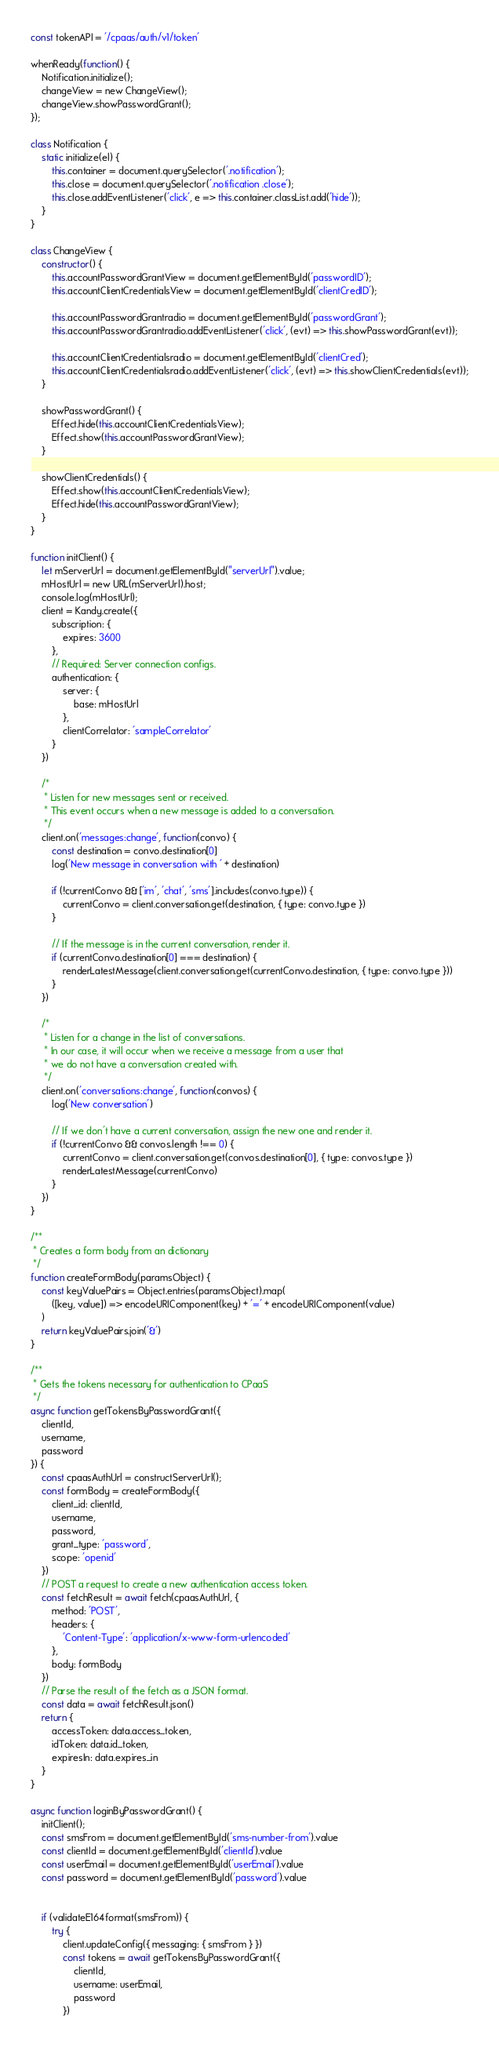Convert code to text. <code><loc_0><loc_0><loc_500><loc_500><_JavaScript_>const tokenAPI = '/cpaas/auth/v1/token'

whenReady(function() {
    Notification.initialize();
    changeView = new ChangeView();
    changeView.showPasswordGrant();
});

class Notification {
    static initialize(el) {
        this.container = document.querySelector('.notification');
        this.close = document.querySelector('.notification .close');
        this.close.addEventListener('click', e => this.container.classList.add('hide'));
    }
}

class ChangeView {
    constructor() {
        this.accountPasswordGrantView = document.getElementById('passwordID');
        this.accountClientCredentialsView = document.getElementById('clientCredID');

        this.accountPasswordGrantradio = document.getElementById('passwordGrant');
        this.accountPasswordGrantradio.addEventListener('click', (evt) => this.showPasswordGrant(evt));

        this.accountClientCredentialsradio = document.getElementById('clientCred');
        this.accountClientCredentialsradio.addEventListener('click', (evt) => this.showClientCredentials(evt));
    }

    showPasswordGrant() {
        Effect.hide(this.accountClientCredentialsView);
        Effect.show(this.accountPasswordGrantView);
    }

    showClientCredentials() {
        Effect.show(this.accountClientCredentialsView);
        Effect.hide(this.accountPasswordGrantView);
    }
}

function initClient() {
    let mServerUrl = document.getElementById("serverUrl").value;
    mHostUrl = new URL(mServerUrl).host;
    console.log(mHostUrl);
    client = Kandy.create({
        subscription: {
            expires: 3600
        },
        // Required: Server connection configs.
        authentication: {
            server: {
                base: mHostUrl
            },
            clientCorrelator: 'sampleCorrelator'
        }
    })

    /*
     * Listen for new messages sent or received.
     * This event occurs when a new message is added to a conversation.
     */
    client.on('messages:change', function(convo) {
        const destination = convo.destination[0]
        log('New message in conversation with ' + destination)

        if (!currentConvo && ['im', 'chat', 'sms'].includes(convo.type)) {
            currentConvo = client.conversation.get(destination, { type: convo.type })
        }

        // If the message is in the current conversation, render it.
        if (currentConvo.destination[0] === destination) {
            renderLatestMessage(client.conversation.get(currentConvo.destination, { type: convo.type }))
        }
    })

    /*
     * Listen for a change in the list of conversations.
     * In our case, it will occur when we receive a message from a user that
     * we do not have a conversation created with.
     */
    client.on('conversations:change', function(convos) {
        log('New conversation')

        // If we don't have a current conversation, assign the new one and render it.
        if (!currentConvo && convos.length !== 0) {
            currentConvo = client.conversation.get(convos.destination[0], { type: convos.type })
            renderLatestMessage(currentConvo)
        }
    })
}

/**
 * Creates a form body from an dictionary
 */
function createFormBody(paramsObject) {
    const keyValuePairs = Object.entries(paramsObject).map(
        ([key, value]) => encodeURIComponent(key) + '=' + encodeURIComponent(value)
    )
    return keyValuePairs.join('&')
}

/**
 * Gets the tokens necessary for authentication to CPaaS
 */
async function getTokensByPasswordGrant({
    clientId,
    username,
    password
}) {
    const cpaasAuthUrl = constructServerUrl();
    const formBody = createFormBody({
        client_id: clientId,
        username,
        password,
        grant_type: 'password',
        scope: 'openid'
    })
    // POST a request to create a new authentication access token.
    const fetchResult = await fetch(cpaasAuthUrl, {
        method: 'POST',
        headers: {
            'Content-Type': 'application/x-www-form-urlencoded'
        },
        body: formBody
    })
    // Parse the result of the fetch as a JSON format.
    const data = await fetchResult.json()
    return {
        accessToken: data.access_token,
        idToken: data.id_token,
        expiresIn: data.expires_in
    }
}

async function loginByPasswordGrant() {
    initClient();
    const smsFrom = document.getElementById('sms-number-from').value
    const clientId = document.getElementById('clientId').value
    const userEmail = document.getElementById('userEmail').value
    const password = document.getElementById('password').value


    if (validateE164format(smsFrom)) {
        try {
            client.updateConfig({ messaging: { smsFrom } })
            const tokens = await getTokensByPasswordGrant({
                clientId,
                username: userEmail,
                password
            })
</code> 